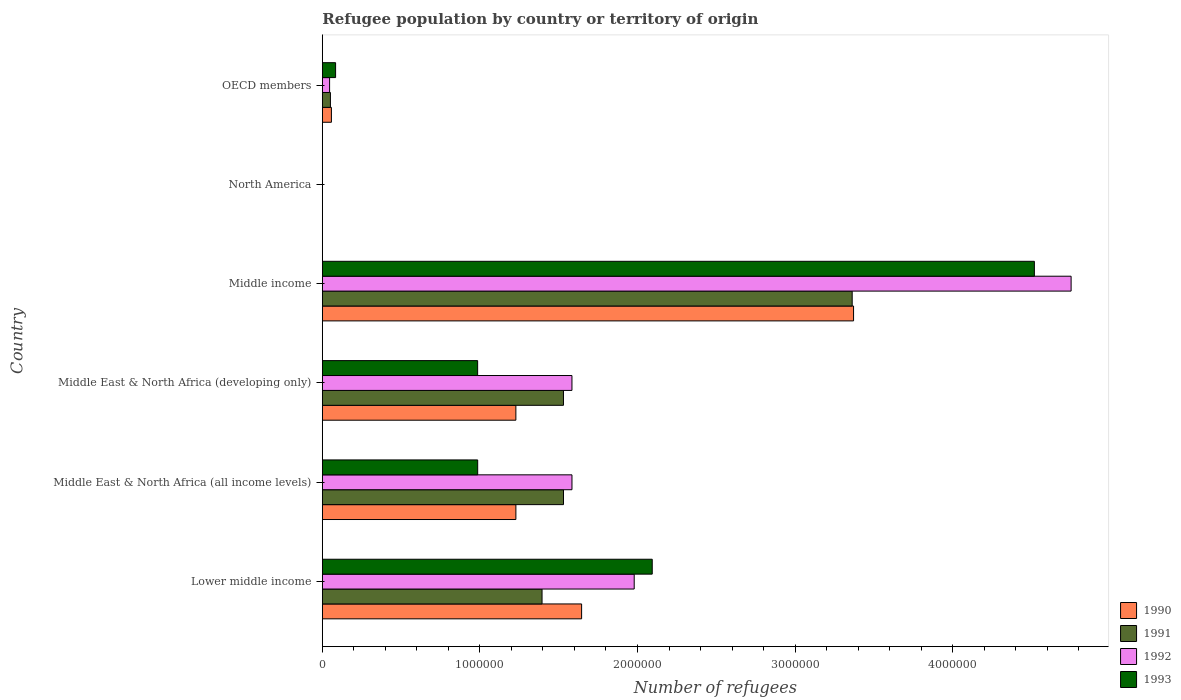Are the number of bars per tick equal to the number of legend labels?
Your response must be concise. Yes. How many bars are there on the 4th tick from the bottom?
Your response must be concise. 4. What is the number of refugees in 1990 in Middle income?
Make the answer very short. 3.37e+06. Across all countries, what is the maximum number of refugees in 1993?
Offer a very short reply. 4.52e+06. In which country was the number of refugees in 1991 maximum?
Your response must be concise. Middle income. What is the total number of refugees in 1990 in the graph?
Your answer should be compact. 7.53e+06. What is the difference between the number of refugees in 1991 in Middle East & North Africa (all income levels) and that in OECD members?
Offer a very short reply. 1.48e+06. What is the difference between the number of refugees in 1992 in Middle income and the number of refugees in 1993 in North America?
Offer a very short reply. 4.75e+06. What is the average number of refugees in 1990 per country?
Offer a very short reply. 1.26e+06. What is the difference between the number of refugees in 1990 and number of refugees in 1993 in Middle East & North Africa (developing only)?
Your response must be concise. 2.43e+05. In how many countries, is the number of refugees in 1992 greater than 1200000 ?
Your response must be concise. 4. What is the ratio of the number of refugees in 1993 in Middle income to that in North America?
Keep it short and to the point. 2.82e+05. Is the number of refugees in 1991 in Lower middle income less than that in Middle income?
Keep it short and to the point. Yes. Is the difference between the number of refugees in 1990 in Lower middle income and Middle East & North Africa (all income levels) greater than the difference between the number of refugees in 1993 in Lower middle income and Middle East & North Africa (all income levels)?
Give a very brief answer. No. What is the difference between the highest and the second highest number of refugees in 1990?
Your response must be concise. 1.73e+06. What is the difference between the highest and the lowest number of refugees in 1993?
Your response must be concise. 4.52e+06. In how many countries, is the number of refugees in 1991 greater than the average number of refugees in 1991 taken over all countries?
Your response must be concise. 4. What does the 3rd bar from the bottom in Middle income represents?
Provide a succinct answer. 1992. Is it the case that in every country, the sum of the number of refugees in 1991 and number of refugees in 1993 is greater than the number of refugees in 1992?
Offer a terse response. Yes. How many bars are there?
Ensure brevity in your answer.  24. Are all the bars in the graph horizontal?
Provide a short and direct response. Yes. How many countries are there in the graph?
Ensure brevity in your answer.  6. What is the difference between two consecutive major ticks on the X-axis?
Give a very brief answer. 1.00e+06. Does the graph contain any zero values?
Offer a terse response. No. Where does the legend appear in the graph?
Your answer should be compact. Bottom right. What is the title of the graph?
Make the answer very short. Refugee population by country or territory of origin. Does "1970" appear as one of the legend labels in the graph?
Your response must be concise. No. What is the label or title of the X-axis?
Your answer should be compact. Number of refugees. What is the Number of refugees in 1990 in Lower middle income?
Provide a short and direct response. 1.65e+06. What is the Number of refugees of 1991 in Lower middle income?
Your response must be concise. 1.39e+06. What is the Number of refugees of 1992 in Lower middle income?
Make the answer very short. 1.98e+06. What is the Number of refugees of 1993 in Lower middle income?
Ensure brevity in your answer.  2.09e+06. What is the Number of refugees in 1990 in Middle East & North Africa (all income levels)?
Make the answer very short. 1.23e+06. What is the Number of refugees in 1991 in Middle East & North Africa (all income levels)?
Offer a terse response. 1.53e+06. What is the Number of refugees of 1992 in Middle East & North Africa (all income levels)?
Keep it short and to the point. 1.58e+06. What is the Number of refugees in 1993 in Middle East & North Africa (all income levels)?
Offer a very short reply. 9.86e+05. What is the Number of refugees of 1990 in Middle East & North Africa (developing only)?
Keep it short and to the point. 1.23e+06. What is the Number of refugees in 1991 in Middle East & North Africa (developing only)?
Provide a succinct answer. 1.53e+06. What is the Number of refugees in 1992 in Middle East & North Africa (developing only)?
Your response must be concise. 1.58e+06. What is the Number of refugees in 1993 in Middle East & North Africa (developing only)?
Give a very brief answer. 9.86e+05. What is the Number of refugees in 1990 in Middle income?
Your response must be concise. 3.37e+06. What is the Number of refugees of 1991 in Middle income?
Ensure brevity in your answer.  3.36e+06. What is the Number of refugees in 1992 in Middle income?
Your answer should be compact. 4.75e+06. What is the Number of refugees of 1993 in Middle income?
Your response must be concise. 4.52e+06. What is the Number of refugees of 1990 in North America?
Make the answer very short. 1. What is the Number of refugees of 1991 in North America?
Give a very brief answer. 12. What is the Number of refugees of 1993 in North America?
Offer a very short reply. 16. What is the Number of refugees in 1990 in OECD members?
Your answer should be very brief. 5.76e+04. What is the Number of refugees in 1991 in OECD members?
Provide a succinct answer. 5.14e+04. What is the Number of refugees in 1992 in OECD members?
Your answer should be compact. 4.61e+04. What is the Number of refugees of 1993 in OECD members?
Provide a succinct answer. 8.41e+04. Across all countries, what is the maximum Number of refugees of 1990?
Give a very brief answer. 3.37e+06. Across all countries, what is the maximum Number of refugees in 1991?
Keep it short and to the point. 3.36e+06. Across all countries, what is the maximum Number of refugees in 1992?
Provide a succinct answer. 4.75e+06. Across all countries, what is the maximum Number of refugees of 1993?
Ensure brevity in your answer.  4.52e+06. Across all countries, what is the minimum Number of refugees of 1991?
Make the answer very short. 12. Across all countries, what is the minimum Number of refugees of 1992?
Offer a terse response. 14. What is the total Number of refugees in 1990 in the graph?
Ensure brevity in your answer.  7.53e+06. What is the total Number of refugees in 1991 in the graph?
Provide a succinct answer. 7.87e+06. What is the total Number of refugees of 1992 in the graph?
Give a very brief answer. 9.94e+06. What is the total Number of refugees in 1993 in the graph?
Provide a succinct answer. 8.67e+06. What is the difference between the Number of refugees in 1990 in Lower middle income and that in Middle East & North Africa (all income levels)?
Keep it short and to the point. 4.17e+05. What is the difference between the Number of refugees in 1991 in Lower middle income and that in Middle East & North Africa (all income levels)?
Your answer should be compact. -1.36e+05. What is the difference between the Number of refugees in 1992 in Lower middle income and that in Middle East & North Africa (all income levels)?
Ensure brevity in your answer.  3.95e+05. What is the difference between the Number of refugees in 1993 in Lower middle income and that in Middle East & North Africa (all income levels)?
Provide a short and direct response. 1.11e+06. What is the difference between the Number of refugees in 1990 in Lower middle income and that in Middle East & North Africa (developing only)?
Offer a terse response. 4.17e+05. What is the difference between the Number of refugees in 1991 in Lower middle income and that in Middle East & North Africa (developing only)?
Provide a succinct answer. -1.36e+05. What is the difference between the Number of refugees of 1992 in Lower middle income and that in Middle East & North Africa (developing only)?
Ensure brevity in your answer.  3.95e+05. What is the difference between the Number of refugees in 1993 in Lower middle income and that in Middle East & North Africa (developing only)?
Offer a terse response. 1.11e+06. What is the difference between the Number of refugees in 1990 in Lower middle income and that in Middle income?
Keep it short and to the point. -1.73e+06. What is the difference between the Number of refugees in 1991 in Lower middle income and that in Middle income?
Offer a terse response. -1.97e+06. What is the difference between the Number of refugees of 1992 in Lower middle income and that in Middle income?
Your answer should be very brief. -2.77e+06. What is the difference between the Number of refugees in 1993 in Lower middle income and that in Middle income?
Your response must be concise. -2.42e+06. What is the difference between the Number of refugees of 1990 in Lower middle income and that in North America?
Offer a very short reply. 1.65e+06. What is the difference between the Number of refugees in 1991 in Lower middle income and that in North America?
Offer a very short reply. 1.39e+06. What is the difference between the Number of refugees in 1992 in Lower middle income and that in North America?
Offer a very short reply. 1.98e+06. What is the difference between the Number of refugees of 1993 in Lower middle income and that in North America?
Your answer should be compact. 2.09e+06. What is the difference between the Number of refugees of 1990 in Lower middle income and that in OECD members?
Offer a terse response. 1.59e+06. What is the difference between the Number of refugees of 1991 in Lower middle income and that in OECD members?
Make the answer very short. 1.34e+06. What is the difference between the Number of refugees of 1992 in Lower middle income and that in OECD members?
Offer a very short reply. 1.93e+06. What is the difference between the Number of refugees of 1993 in Lower middle income and that in OECD members?
Your answer should be compact. 2.01e+06. What is the difference between the Number of refugees of 1991 in Middle East & North Africa (all income levels) and that in Middle East & North Africa (developing only)?
Offer a terse response. 128. What is the difference between the Number of refugees in 1992 in Middle East & North Africa (all income levels) and that in Middle East & North Africa (developing only)?
Your answer should be compact. 168. What is the difference between the Number of refugees in 1993 in Middle East & North Africa (all income levels) and that in Middle East & North Africa (developing only)?
Keep it short and to the point. 274. What is the difference between the Number of refugees in 1990 in Middle East & North Africa (all income levels) and that in Middle income?
Give a very brief answer. -2.14e+06. What is the difference between the Number of refugees of 1991 in Middle East & North Africa (all income levels) and that in Middle income?
Your answer should be very brief. -1.83e+06. What is the difference between the Number of refugees in 1992 in Middle East & North Africa (all income levels) and that in Middle income?
Give a very brief answer. -3.17e+06. What is the difference between the Number of refugees in 1993 in Middle East & North Africa (all income levels) and that in Middle income?
Make the answer very short. -3.53e+06. What is the difference between the Number of refugees of 1990 in Middle East & North Africa (all income levels) and that in North America?
Keep it short and to the point. 1.23e+06. What is the difference between the Number of refugees in 1991 in Middle East & North Africa (all income levels) and that in North America?
Provide a short and direct response. 1.53e+06. What is the difference between the Number of refugees of 1992 in Middle East & North Africa (all income levels) and that in North America?
Your answer should be compact. 1.58e+06. What is the difference between the Number of refugees in 1993 in Middle East & North Africa (all income levels) and that in North America?
Ensure brevity in your answer.  9.86e+05. What is the difference between the Number of refugees of 1990 in Middle East & North Africa (all income levels) and that in OECD members?
Ensure brevity in your answer.  1.17e+06. What is the difference between the Number of refugees in 1991 in Middle East & North Africa (all income levels) and that in OECD members?
Your answer should be compact. 1.48e+06. What is the difference between the Number of refugees in 1992 in Middle East & North Africa (all income levels) and that in OECD members?
Make the answer very short. 1.54e+06. What is the difference between the Number of refugees in 1993 in Middle East & North Africa (all income levels) and that in OECD members?
Provide a short and direct response. 9.02e+05. What is the difference between the Number of refugees of 1990 in Middle East & North Africa (developing only) and that in Middle income?
Ensure brevity in your answer.  -2.14e+06. What is the difference between the Number of refugees in 1991 in Middle East & North Africa (developing only) and that in Middle income?
Make the answer very short. -1.83e+06. What is the difference between the Number of refugees in 1992 in Middle East & North Africa (developing only) and that in Middle income?
Provide a short and direct response. -3.17e+06. What is the difference between the Number of refugees of 1993 in Middle East & North Africa (developing only) and that in Middle income?
Your answer should be very brief. -3.53e+06. What is the difference between the Number of refugees in 1990 in Middle East & North Africa (developing only) and that in North America?
Give a very brief answer. 1.23e+06. What is the difference between the Number of refugees of 1991 in Middle East & North Africa (developing only) and that in North America?
Offer a very short reply. 1.53e+06. What is the difference between the Number of refugees in 1992 in Middle East & North Africa (developing only) and that in North America?
Provide a short and direct response. 1.58e+06. What is the difference between the Number of refugees in 1993 in Middle East & North Africa (developing only) and that in North America?
Ensure brevity in your answer.  9.86e+05. What is the difference between the Number of refugees of 1990 in Middle East & North Africa (developing only) and that in OECD members?
Ensure brevity in your answer.  1.17e+06. What is the difference between the Number of refugees of 1991 in Middle East & North Africa (developing only) and that in OECD members?
Your answer should be very brief. 1.48e+06. What is the difference between the Number of refugees in 1992 in Middle East & North Africa (developing only) and that in OECD members?
Provide a succinct answer. 1.54e+06. What is the difference between the Number of refugees in 1993 in Middle East & North Africa (developing only) and that in OECD members?
Ensure brevity in your answer.  9.01e+05. What is the difference between the Number of refugees of 1990 in Middle income and that in North America?
Keep it short and to the point. 3.37e+06. What is the difference between the Number of refugees in 1991 in Middle income and that in North America?
Offer a terse response. 3.36e+06. What is the difference between the Number of refugees in 1992 in Middle income and that in North America?
Provide a succinct answer. 4.75e+06. What is the difference between the Number of refugees of 1993 in Middle income and that in North America?
Your response must be concise. 4.52e+06. What is the difference between the Number of refugees of 1990 in Middle income and that in OECD members?
Make the answer very short. 3.31e+06. What is the difference between the Number of refugees of 1991 in Middle income and that in OECD members?
Offer a terse response. 3.31e+06. What is the difference between the Number of refugees of 1992 in Middle income and that in OECD members?
Provide a succinct answer. 4.71e+06. What is the difference between the Number of refugees in 1993 in Middle income and that in OECD members?
Your response must be concise. 4.43e+06. What is the difference between the Number of refugees in 1990 in North America and that in OECD members?
Offer a very short reply. -5.76e+04. What is the difference between the Number of refugees in 1991 in North America and that in OECD members?
Offer a very short reply. -5.14e+04. What is the difference between the Number of refugees in 1992 in North America and that in OECD members?
Offer a very short reply. -4.61e+04. What is the difference between the Number of refugees in 1993 in North America and that in OECD members?
Ensure brevity in your answer.  -8.41e+04. What is the difference between the Number of refugees in 1990 in Lower middle income and the Number of refugees in 1991 in Middle East & North Africa (all income levels)?
Provide a short and direct response. 1.15e+05. What is the difference between the Number of refugees in 1990 in Lower middle income and the Number of refugees in 1992 in Middle East & North Africa (all income levels)?
Your answer should be very brief. 6.11e+04. What is the difference between the Number of refugees of 1990 in Lower middle income and the Number of refugees of 1993 in Middle East & North Africa (all income levels)?
Ensure brevity in your answer.  6.59e+05. What is the difference between the Number of refugees in 1991 in Lower middle income and the Number of refugees in 1992 in Middle East & North Africa (all income levels)?
Your answer should be compact. -1.90e+05. What is the difference between the Number of refugees in 1991 in Lower middle income and the Number of refugees in 1993 in Middle East & North Africa (all income levels)?
Your answer should be compact. 4.08e+05. What is the difference between the Number of refugees of 1992 in Lower middle income and the Number of refugees of 1993 in Middle East & North Africa (all income levels)?
Keep it short and to the point. 9.93e+05. What is the difference between the Number of refugees of 1990 in Lower middle income and the Number of refugees of 1991 in Middle East & North Africa (developing only)?
Ensure brevity in your answer.  1.15e+05. What is the difference between the Number of refugees of 1990 in Lower middle income and the Number of refugees of 1992 in Middle East & North Africa (developing only)?
Keep it short and to the point. 6.13e+04. What is the difference between the Number of refugees in 1990 in Lower middle income and the Number of refugees in 1993 in Middle East & North Africa (developing only)?
Give a very brief answer. 6.60e+05. What is the difference between the Number of refugees of 1991 in Lower middle income and the Number of refugees of 1992 in Middle East & North Africa (developing only)?
Keep it short and to the point. -1.90e+05. What is the difference between the Number of refugees in 1991 in Lower middle income and the Number of refugees in 1993 in Middle East & North Africa (developing only)?
Offer a very short reply. 4.09e+05. What is the difference between the Number of refugees in 1992 in Lower middle income and the Number of refugees in 1993 in Middle East & North Africa (developing only)?
Your answer should be compact. 9.93e+05. What is the difference between the Number of refugees in 1990 in Lower middle income and the Number of refugees in 1991 in Middle income?
Make the answer very short. -1.72e+06. What is the difference between the Number of refugees of 1990 in Lower middle income and the Number of refugees of 1992 in Middle income?
Your answer should be very brief. -3.11e+06. What is the difference between the Number of refugees of 1990 in Lower middle income and the Number of refugees of 1993 in Middle income?
Your answer should be very brief. -2.87e+06. What is the difference between the Number of refugees of 1991 in Lower middle income and the Number of refugees of 1992 in Middle income?
Offer a terse response. -3.36e+06. What is the difference between the Number of refugees of 1991 in Lower middle income and the Number of refugees of 1993 in Middle income?
Make the answer very short. -3.12e+06. What is the difference between the Number of refugees in 1992 in Lower middle income and the Number of refugees in 1993 in Middle income?
Keep it short and to the point. -2.54e+06. What is the difference between the Number of refugees in 1990 in Lower middle income and the Number of refugees in 1991 in North America?
Your answer should be compact. 1.65e+06. What is the difference between the Number of refugees in 1990 in Lower middle income and the Number of refugees in 1992 in North America?
Keep it short and to the point. 1.65e+06. What is the difference between the Number of refugees in 1990 in Lower middle income and the Number of refugees in 1993 in North America?
Offer a very short reply. 1.65e+06. What is the difference between the Number of refugees in 1991 in Lower middle income and the Number of refugees in 1992 in North America?
Ensure brevity in your answer.  1.39e+06. What is the difference between the Number of refugees of 1991 in Lower middle income and the Number of refugees of 1993 in North America?
Offer a terse response. 1.39e+06. What is the difference between the Number of refugees of 1992 in Lower middle income and the Number of refugees of 1993 in North America?
Provide a succinct answer. 1.98e+06. What is the difference between the Number of refugees of 1990 in Lower middle income and the Number of refugees of 1991 in OECD members?
Offer a terse response. 1.59e+06. What is the difference between the Number of refugees of 1990 in Lower middle income and the Number of refugees of 1992 in OECD members?
Offer a very short reply. 1.60e+06. What is the difference between the Number of refugees in 1990 in Lower middle income and the Number of refugees in 1993 in OECD members?
Your answer should be compact. 1.56e+06. What is the difference between the Number of refugees of 1991 in Lower middle income and the Number of refugees of 1992 in OECD members?
Offer a very short reply. 1.35e+06. What is the difference between the Number of refugees of 1991 in Lower middle income and the Number of refugees of 1993 in OECD members?
Your answer should be very brief. 1.31e+06. What is the difference between the Number of refugees in 1992 in Lower middle income and the Number of refugees in 1993 in OECD members?
Offer a terse response. 1.89e+06. What is the difference between the Number of refugees in 1990 in Middle East & North Africa (all income levels) and the Number of refugees in 1991 in Middle East & North Africa (developing only)?
Ensure brevity in your answer.  -3.02e+05. What is the difference between the Number of refugees of 1990 in Middle East & North Africa (all income levels) and the Number of refugees of 1992 in Middle East & North Africa (developing only)?
Provide a succinct answer. -3.56e+05. What is the difference between the Number of refugees of 1990 in Middle East & North Africa (all income levels) and the Number of refugees of 1993 in Middle East & North Africa (developing only)?
Offer a very short reply. 2.43e+05. What is the difference between the Number of refugees in 1991 in Middle East & North Africa (all income levels) and the Number of refugees in 1992 in Middle East & North Africa (developing only)?
Offer a very short reply. -5.36e+04. What is the difference between the Number of refugees of 1991 in Middle East & North Africa (all income levels) and the Number of refugees of 1993 in Middle East & North Africa (developing only)?
Keep it short and to the point. 5.45e+05. What is the difference between the Number of refugees of 1992 in Middle East & North Africa (all income levels) and the Number of refugees of 1993 in Middle East & North Africa (developing only)?
Your answer should be very brief. 5.99e+05. What is the difference between the Number of refugees in 1990 in Middle East & North Africa (all income levels) and the Number of refugees in 1991 in Middle income?
Your answer should be very brief. -2.13e+06. What is the difference between the Number of refugees of 1990 in Middle East & North Africa (all income levels) and the Number of refugees of 1992 in Middle income?
Provide a short and direct response. -3.52e+06. What is the difference between the Number of refugees in 1990 in Middle East & North Africa (all income levels) and the Number of refugees in 1993 in Middle income?
Your response must be concise. -3.29e+06. What is the difference between the Number of refugees of 1991 in Middle East & North Africa (all income levels) and the Number of refugees of 1992 in Middle income?
Provide a short and direct response. -3.22e+06. What is the difference between the Number of refugees of 1991 in Middle East & North Africa (all income levels) and the Number of refugees of 1993 in Middle income?
Offer a terse response. -2.99e+06. What is the difference between the Number of refugees of 1992 in Middle East & North Africa (all income levels) and the Number of refugees of 1993 in Middle income?
Offer a very short reply. -2.93e+06. What is the difference between the Number of refugees in 1990 in Middle East & North Africa (all income levels) and the Number of refugees in 1991 in North America?
Provide a short and direct response. 1.23e+06. What is the difference between the Number of refugees in 1990 in Middle East & North Africa (all income levels) and the Number of refugees in 1992 in North America?
Provide a short and direct response. 1.23e+06. What is the difference between the Number of refugees in 1990 in Middle East & North Africa (all income levels) and the Number of refugees in 1993 in North America?
Keep it short and to the point. 1.23e+06. What is the difference between the Number of refugees in 1991 in Middle East & North Africa (all income levels) and the Number of refugees in 1992 in North America?
Your response must be concise. 1.53e+06. What is the difference between the Number of refugees in 1991 in Middle East & North Africa (all income levels) and the Number of refugees in 1993 in North America?
Your response must be concise. 1.53e+06. What is the difference between the Number of refugees in 1992 in Middle East & North Africa (all income levels) and the Number of refugees in 1993 in North America?
Keep it short and to the point. 1.58e+06. What is the difference between the Number of refugees in 1990 in Middle East & North Africa (all income levels) and the Number of refugees in 1991 in OECD members?
Offer a very short reply. 1.18e+06. What is the difference between the Number of refugees of 1990 in Middle East & North Africa (all income levels) and the Number of refugees of 1992 in OECD members?
Provide a short and direct response. 1.18e+06. What is the difference between the Number of refugees in 1990 in Middle East & North Africa (all income levels) and the Number of refugees in 1993 in OECD members?
Keep it short and to the point. 1.14e+06. What is the difference between the Number of refugees in 1991 in Middle East & North Africa (all income levels) and the Number of refugees in 1992 in OECD members?
Ensure brevity in your answer.  1.48e+06. What is the difference between the Number of refugees of 1991 in Middle East & North Africa (all income levels) and the Number of refugees of 1993 in OECD members?
Your answer should be compact. 1.45e+06. What is the difference between the Number of refugees in 1992 in Middle East & North Africa (all income levels) and the Number of refugees in 1993 in OECD members?
Make the answer very short. 1.50e+06. What is the difference between the Number of refugees in 1990 in Middle East & North Africa (developing only) and the Number of refugees in 1991 in Middle income?
Ensure brevity in your answer.  -2.13e+06. What is the difference between the Number of refugees of 1990 in Middle East & North Africa (developing only) and the Number of refugees of 1992 in Middle income?
Keep it short and to the point. -3.52e+06. What is the difference between the Number of refugees of 1990 in Middle East & North Africa (developing only) and the Number of refugees of 1993 in Middle income?
Provide a short and direct response. -3.29e+06. What is the difference between the Number of refugees of 1991 in Middle East & North Africa (developing only) and the Number of refugees of 1992 in Middle income?
Give a very brief answer. -3.22e+06. What is the difference between the Number of refugees of 1991 in Middle East & North Africa (developing only) and the Number of refugees of 1993 in Middle income?
Offer a terse response. -2.99e+06. What is the difference between the Number of refugees in 1992 in Middle East & North Africa (developing only) and the Number of refugees in 1993 in Middle income?
Provide a succinct answer. -2.93e+06. What is the difference between the Number of refugees in 1990 in Middle East & North Africa (developing only) and the Number of refugees in 1991 in North America?
Your answer should be compact. 1.23e+06. What is the difference between the Number of refugees of 1990 in Middle East & North Africa (developing only) and the Number of refugees of 1992 in North America?
Give a very brief answer. 1.23e+06. What is the difference between the Number of refugees in 1990 in Middle East & North Africa (developing only) and the Number of refugees in 1993 in North America?
Provide a short and direct response. 1.23e+06. What is the difference between the Number of refugees of 1991 in Middle East & North Africa (developing only) and the Number of refugees of 1992 in North America?
Your answer should be compact. 1.53e+06. What is the difference between the Number of refugees in 1991 in Middle East & North Africa (developing only) and the Number of refugees in 1993 in North America?
Offer a terse response. 1.53e+06. What is the difference between the Number of refugees of 1992 in Middle East & North Africa (developing only) and the Number of refugees of 1993 in North America?
Give a very brief answer. 1.58e+06. What is the difference between the Number of refugees of 1990 in Middle East & North Africa (developing only) and the Number of refugees of 1991 in OECD members?
Offer a terse response. 1.18e+06. What is the difference between the Number of refugees of 1990 in Middle East & North Africa (developing only) and the Number of refugees of 1992 in OECD members?
Ensure brevity in your answer.  1.18e+06. What is the difference between the Number of refugees in 1990 in Middle East & North Africa (developing only) and the Number of refugees in 1993 in OECD members?
Your answer should be compact. 1.14e+06. What is the difference between the Number of refugees of 1991 in Middle East & North Africa (developing only) and the Number of refugees of 1992 in OECD members?
Keep it short and to the point. 1.48e+06. What is the difference between the Number of refugees in 1991 in Middle East & North Africa (developing only) and the Number of refugees in 1993 in OECD members?
Provide a short and direct response. 1.45e+06. What is the difference between the Number of refugees of 1992 in Middle East & North Africa (developing only) and the Number of refugees of 1993 in OECD members?
Make the answer very short. 1.50e+06. What is the difference between the Number of refugees of 1990 in Middle income and the Number of refugees of 1991 in North America?
Keep it short and to the point. 3.37e+06. What is the difference between the Number of refugees in 1990 in Middle income and the Number of refugees in 1992 in North America?
Provide a short and direct response. 3.37e+06. What is the difference between the Number of refugees in 1990 in Middle income and the Number of refugees in 1993 in North America?
Make the answer very short. 3.37e+06. What is the difference between the Number of refugees in 1991 in Middle income and the Number of refugees in 1992 in North America?
Your answer should be compact. 3.36e+06. What is the difference between the Number of refugees of 1991 in Middle income and the Number of refugees of 1993 in North America?
Provide a short and direct response. 3.36e+06. What is the difference between the Number of refugees of 1992 in Middle income and the Number of refugees of 1993 in North America?
Offer a terse response. 4.75e+06. What is the difference between the Number of refugees in 1990 in Middle income and the Number of refugees in 1991 in OECD members?
Ensure brevity in your answer.  3.32e+06. What is the difference between the Number of refugees of 1990 in Middle income and the Number of refugees of 1992 in OECD members?
Ensure brevity in your answer.  3.32e+06. What is the difference between the Number of refugees of 1990 in Middle income and the Number of refugees of 1993 in OECD members?
Your answer should be very brief. 3.29e+06. What is the difference between the Number of refugees of 1991 in Middle income and the Number of refugees of 1992 in OECD members?
Your answer should be compact. 3.32e+06. What is the difference between the Number of refugees in 1991 in Middle income and the Number of refugees in 1993 in OECD members?
Provide a succinct answer. 3.28e+06. What is the difference between the Number of refugees in 1992 in Middle income and the Number of refugees in 1993 in OECD members?
Your response must be concise. 4.67e+06. What is the difference between the Number of refugees of 1990 in North America and the Number of refugees of 1991 in OECD members?
Your answer should be compact. -5.14e+04. What is the difference between the Number of refugees of 1990 in North America and the Number of refugees of 1992 in OECD members?
Your response must be concise. -4.61e+04. What is the difference between the Number of refugees in 1990 in North America and the Number of refugees in 1993 in OECD members?
Provide a short and direct response. -8.41e+04. What is the difference between the Number of refugees in 1991 in North America and the Number of refugees in 1992 in OECD members?
Give a very brief answer. -4.61e+04. What is the difference between the Number of refugees in 1991 in North America and the Number of refugees in 1993 in OECD members?
Give a very brief answer. -8.41e+04. What is the difference between the Number of refugees in 1992 in North America and the Number of refugees in 1993 in OECD members?
Provide a succinct answer. -8.41e+04. What is the average Number of refugees in 1990 per country?
Your response must be concise. 1.26e+06. What is the average Number of refugees of 1991 per country?
Provide a short and direct response. 1.31e+06. What is the average Number of refugees of 1992 per country?
Your response must be concise. 1.66e+06. What is the average Number of refugees in 1993 per country?
Make the answer very short. 1.44e+06. What is the difference between the Number of refugees of 1990 and Number of refugees of 1991 in Lower middle income?
Offer a terse response. 2.51e+05. What is the difference between the Number of refugees in 1990 and Number of refugees in 1992 in Lower middle income?
Provide a short and direct response. -3.34e+05. What is the difference between the Number of refugees of 1990 and Number of refugees of 1993 in Lower middle income?
Give a very brief answer. -4.48e+05. What is the difference between the Number of refugees of 1991 and Number of refugees of 1992 in Lower middle income?
Keep it short and to the point. -5.85e+05. What is the difference between the Number of refugees in 1991 and Number of refugees in 1993 in Lower middle income?
Provide a short and direct response. -6.99e+05. What is the difference between the Number of refugees in 1992 and Number of refugees in 1993 in Lower middle income?
Keep it short and to the point. -1.15e+05. What is the difference between the Number of refugees of 1990 and Number of refugees of 1991 in Middle East & North Africa (all income levels)?
Ensure brevity in your answer.  -3.02e+05. What is the difference between the Number of refugees of 1990 and Number of refugees of 1992 in Middle East & North Africa (all income levels)?
Keep it short and to the point. -3.56e+05. What is the difference between the Number of refugees in 1990 and Number of refugees in 1993 in Middle East & North Africa (all income levels)?
Your answer should be very brief. 2.42e+05. What is the difference between the Number of refugees in 1991 and Number of refugees in 1992 in Middle East & North Africa (all income levels)?
Ensure brevity in your answer.  -5.38e+04. What is the difference between the Number of refugees of 1991 and Number of refugees of 1993 in Middle East & North Africa (all income levels)?
Keep it short and to the point. 5.44e+05. What is the difference between the Number of refugees of 1992 and Number of refugees of 1993 in Middle East & North Africa (all income levels)?
Your answer should be compact. 5.98e+05. What is the difference between the Number of refugees in 1990 and Number of refugees in 1991 in Middle East & North Africa (developing only)?
Your answer should be compact. -3.02e+05. What is the difference between the Number of refugees of 1990 and Number of refugees of 1992 in Middle East & North Africa (developing only)?
Make the answer very short. -3.56e+05. What is the difference between the Number of refugees of 1990 and Number of refugees of 1993 in Middle East & North Africa (developing only)?
Offer a terse response. 2.43e+05. What is the difference between the Number of refugees in 1991 and Number of refugees in 1992 in Middle East & North Africa (developing only)?
Your answer should be compact. -5.38e+04. What is the difference between the Number of refugees of 1991 and Number of refugees of 1993 in Middle East & North Africa (developing only)?
Give a very brief answer. 5.45e+05. What is the difference between the Number of refugees of 1992 and Number of refugees of 1993 in Middle East & North Africa (developing only)?
Provide a succinct answer. 5.98e+05. What is the difference between the Number of refugees in 1990 and Number of refugees in 1991 in Middle income?
Ensure brevity in your answer.  8677. What is the difference between the Number of refugees of 1990 and Number of refugees of 1992 in Middle income?
Your response must be concise. -1.38e+06. What is the difference between the Number of refugees of 1990 and Number of refugees of 1993 in Middle income?
Your answer should be compact. -1.15e+06. What is the difference between the Number of refugees of 1991 and Number of refugees of 1992 in Middle income?
Give a very brief answer. -1.39e+06. What is the difference between the Number of refugees in 1991 and Number of refugees in 1993 in Middle income?
Make the answer very short. -1.16e+06. What is the difference between the Number of refugees of 1992 and Number of refugees of 1993 in Middle income?
Provide a short and direct response. 2.33e+05. What is the difference between the Number of refugees in 1990 and Number of refugees in 1991 in North America?
Ensure brevity in your answer.  -11. What is the difference between the Number of refugees in 1990 and Number of refugees in 1991 in OECD members?
Give a very brief answer. 6228. What is the difference between the Number of refugees of 1990 and Number of refugees of 1992 in OECD members?
Give a very brief answer. 1.15e+04. What is the difference between the Number of refugees of 1990 and Number of refugees of 1993 in OECD members?
Offer a very short reply. -2.65e+04. What is the difference between the Number of refugees in 1991 and Number of refugees in 1992 in OECD members?
Your answer should be very brief. 5289. What is the difference between the Number of refugees of 1991 and Number of refugees of 1993 in OECD members?
Provide a succinct answer. -3.28e+04. What is the difference between the Number of refugees of 1992 and Number of refugees of 1993 in OECD members?
Your answer should be compact. -3.80e+04. What is the ratio of the Number of refugees in 1990 in Lower middle income to that in Middle East & North Africa (all income levels)?
Your answer should be compact. 1.34. What is the ratio of the Number of refugees in 1991 in Lower middle income to that in Middle East & North Africa (all income levels)?
Ensure brevity in your answer.  0.91. What is the ratio of the Number of refugees of 1992 in Lower middle income to that in Middle East & North Africa (all income levels)?
Ensure brevity in your answer.  1.25. What is the ratio of the Number of refugees in 1993 in Lower middle income to that in Middle East & North Africa (all income levels)?
Your answer should be compact. 2.12. What is the ratio of the Number of refugees of 1990 in Lower middle income to that in Middle East & North Africa (developing only)?
Provide a short and direct response. 1.34. What is the ratio of the Number of refugees of 1991 in Lower middle income to that in Middle East & North Africa (developing only)?
Your answer should be compact. 0.91. What is the ratio of the Number of refugees in 1992 in Lower middle income to that in Middle East & North Africa (developing only)?
Give a very brief answer. 1.25. What is the ratio of the Number of refugees of 1993 in Lower middle income to that in Middle East & North Africa (developing only)?
Make the answer very short. 2.12. What is the ratio of the Number of refugees in 1990 in Lower middle income to that in Middle income?
Your response must be concise. 0.49. What is the ratio of the Number of refugees of 1991 in Lower middle income to that in Middle income?
Provide a short and direct response. 0.41. What is the ratio of the Number of refugees of 1992 in Lower middle income to that in Middle income?
Make the answer very short. 0.42. What is the ratio of the Number of refugees of 1993 in Lower middle income to that in Middle income?
Your answer should be compact. 0.46. What is the ratio of the Number of refugees in 1990 in Lower middle income to that in North America?
Your answer should be compact. 1.65e+06. What is the ratio of the Number of refugees of 1991 in Lower middle income to that in North America?
Provide a short and direct response. 1.16e+05. What is the ratio of the Number of refugees in 1992 in Lower middle income to that in North America?
Provide a short and direct response. 1.41e+05. What is the ratio of the Number of refugees of 1993 in Lower middle income to that in North America?
Provide a succinct answer. 1.31e+05. What is the ratio of the Number of refugees in 1990 in Lower middle income to that in OECD members?
Make the answer very short. 28.56. What is the ratio of the Number of refugees in 1991 in Lower middle income to that in OECD members?
Offer a very short reply. 27.13. What is the ratio of the Number of refugees in 1992 in Lower middle income to that in OECD members?
Provide a short and direct response. 42.93. What is the ratio of the Number of refugees in 1993 in Lower middle income to that in OECD members?
Offer a terse response. 24.88. What is the ratio of the Number of refugees of 1992 in Middle East & North Africa (all income levels) to that in Middle East & North Africa (developing only)?
Provide a succinct answer. 1. What is the ratio of the Number of refugees of 1990 in Middle East & North Africa (all income levels) to that in Middle income?
Provide a succinct answer. 0.36. What is the ratio of the Number of refugees in 1991 in Middle East & North Africa (all income levels) to that in Middle income?
Your answer should be very brief. 0.46. What is the ratio of the Number of refugees in 1992 in Middle East & North Africa (all income levels) to that in Middle income?
Make the answer very short. 0.33. What is the ratio of the Number of refugees in 1993 in Middle East & North Africa (all income levels) to that in Middle income?
Offer a terse response. 0.22. What is the ratio of the Number of refugees in 1990 in Middle East & North Africa (all income levels) to that in North America?
Ensure brevity in your answer.  1.23e+06. What is the ratio of the Number of refugees of 1991 in Middle East & North Africa (all income levels) to that in North America?
Provide a succinct answer. 1.28e+05. What is the ratio of the Number of refugees of 1992 in Middle East & North Africa (all income levels) to that in North America?
Make the answer very short. 1.13e+05. What is the ratio of the Number of refugees of 1993 in Middle East & North Africa (all income levels) to that in North America?
Your response must be concise. 6.16e+04. What is the ratio of the Number of refugees of 1990 in Middle East & North Africa (all income levels) to that in OECD members?
Make the answer very short. 21.32. What is the ratio of the Number of refugees of 1991 in Middle East & North Africa (all income levels) to that in OECD members?
Ensure brevity in your answer.  29.78. What is the ratio of the Number of refugees in 1992 in Middle East & North Africa (all income levels) to that in OECD members?
Your answer should be very brief. 34.37. What is the ratio of the Number of refugees of 1993 in Middle East & North Africa (all income levels) to that in OECD members?
Make the answer very short. 11.72. What is the ratio of the Number of refugees in 1990 in Middle East & North Africa (developing only) to that in Middle income?
Give a very brief answer. 0.36. What is the ratio of the Number of refugees of 1991 in Middle East & North Africa (developing only) to that in Middle income?
Your answer should be very brief. 0.46. What is the ratio of the Number of refugees in 1992 in Middle East & North Africa (developing only) to that in Middle income?
Your answer should be compact. 0.33. What is the ratio of the Number of refugees in 1993 in Middle East & North Africa (developing only) to that in Middle income?
Your response must be concise. 0.22. What is the ratio of the Number of refugees in 1990 in Middle East & North Africa (developing only) to that in North America?
Offer a terse response. 1.23e+06. What is the ratio of the Number of refugees in 1991 in Middle East & North Africa (developing only) to that in North America?
Your answer should be very brief. 1.28e+05. What is the ratio of the Number of refugees of 1992 in Middle East & North Africa (developing only) to that in North America?
Provide a short and direct response. 1.13e+05. What is the ratio of the Number of refugees of 1993 in Middle East & North Africa (developing only) to that in North America?
Your response must be concise. 6.16e+04. What is the ratio of the Number of refugees of 1990 in Middle East & North Africa (developing only) to that in OECD members?
Give a very brief answer. 21.32. What is the ratio of the Number of refugees of 1991 in Middle East & North Africa (developing only) to that in OECD members?
Provide a succinct answer. 29.78. What is the ratio of the Number of refugees of 1992 in Middle East & North Africa (developing only) to that in OECD members?
Your answer should be very brief. 34.36. What is the ratio of the Number of refugees in 1993 in Middle East & North Africa (developing only) to that in OECD members?
Offer a terse response. 11.71. What is the ratio of the Number of refugees in 1990 in Middle income to that in North America?
Your answer should be very brief. 3.37e+06. What is the ratio of the Number of refugees in 1991 in Middle income to that in North America?
Provide a short and direct response. 2.80e+05. What is the ratio of the Number of refugees of 1992 in Middle income to that in North America?
Your answer should be compact. 3.39e+05. What is the ratio of the Number of refugees of 1993 in Middle income to that in North America?
Ensure brevity in your answer.  2.82e+05. What is the ratio of the Number of refugees in 1990 in Middle income to that in OECD members?
Your answer should be compact. 58.51. What is the ratio of the Number of refugees in 1991 in Middle income to that in OECD members?
Keep it short and to the point. 65.44. What is the ratio of the Number of refugees of 1992 in Middle income to that in OECD members?
Keep it short and to the point. 103.08. What is the ratio of the Number of refugees of 1993 in Middle income to that in OECD members?
Ensure brevity in your answer.  53.7. What is the ratio of the Number of refugees in 1990 in North America to that in OECD members?
Offer a terse response. 0. What is the ratio of the Number of refugees in 1991 in North America to that in OECD members?
Offer a terse response. 0. What is the ratio of the Number of refugees of 1992 in North America to that in OECD members?
Your response must be concise. 0. What is the ratio of the Number of refugees in 1993 in North America to that in OECD members?
Your answer should be very brief. 0. What is the difference between the highest and the second highest Number of refugees of 1990?
Provide a short and direct response. 1.73e+06. What is the difference between the highest and the second highest Number of refugees of 1991?
Provide a succinct answer. 1.83e+06. What is the difference between the highest and the second highest Number of refugees in 1992?
Provide a short and direct response. 2.77e+06. What is the difference between the highest and the second highest Number of refugees in 1993?
Make the answer very short. 2.42e+06. What is the difference between the highest and the lowest Number of refugees of 1990?
Keep it short and to the point. 3.37e+06. What is the difference between the highest and the lowest Number of refugees of 1991?
Ensure brevity in your answer.  3.36e+06. What is the difference between the highest and the lowest Number of refugees of 1992?
Your answer should be very brief. 4.75e+06. What is the difference between the highest and the lowest Number of refugees in 1993?
Make the answer very short. 4.52e+06. 